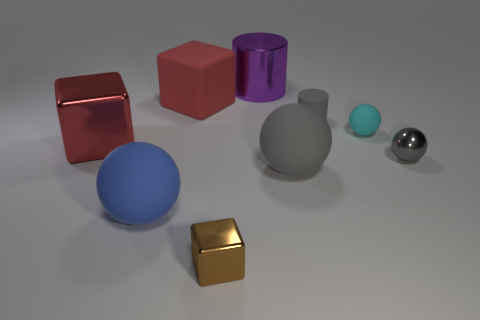Is the tiny cylinder the same color as the metallic ball?
Your response must be concise. Yes. Are there any other things that have the same color as the matte cube?
Provide a succinct answer. Yes. There is a big rubber object right of the big red matte thing; does it have the same color as the small matte cylinder?
Make the answer very short. Yes. The big red matte object has what shape?
Your answer should be very brief. Cube. What is the material of the big block on the left side of the blue rubber ball?
Give a very brief answer. Metal. There is a rubber cylinder; is it the same color as the small shiny thing that is on the right side of the tiny brown block?
Provide a short and direct response. Yes. How many objects are things to the left of the large purple cylinder or large cubes that are behind the big metal cube?
Make the answer very short. 4. There is a thing that is both on the right side of the large matte cube and left of the large cylinder; what color is it?
Your response must be concise. Brown. Is the number of purple objects greater than the number of large gray metal objects?
Ensure brevity in your answer.  Yes. Is the shape of the small metal thing that is behind the brown block the same as  the large gray rubber thing?
Ensure brevity in your answer.  Yes. 